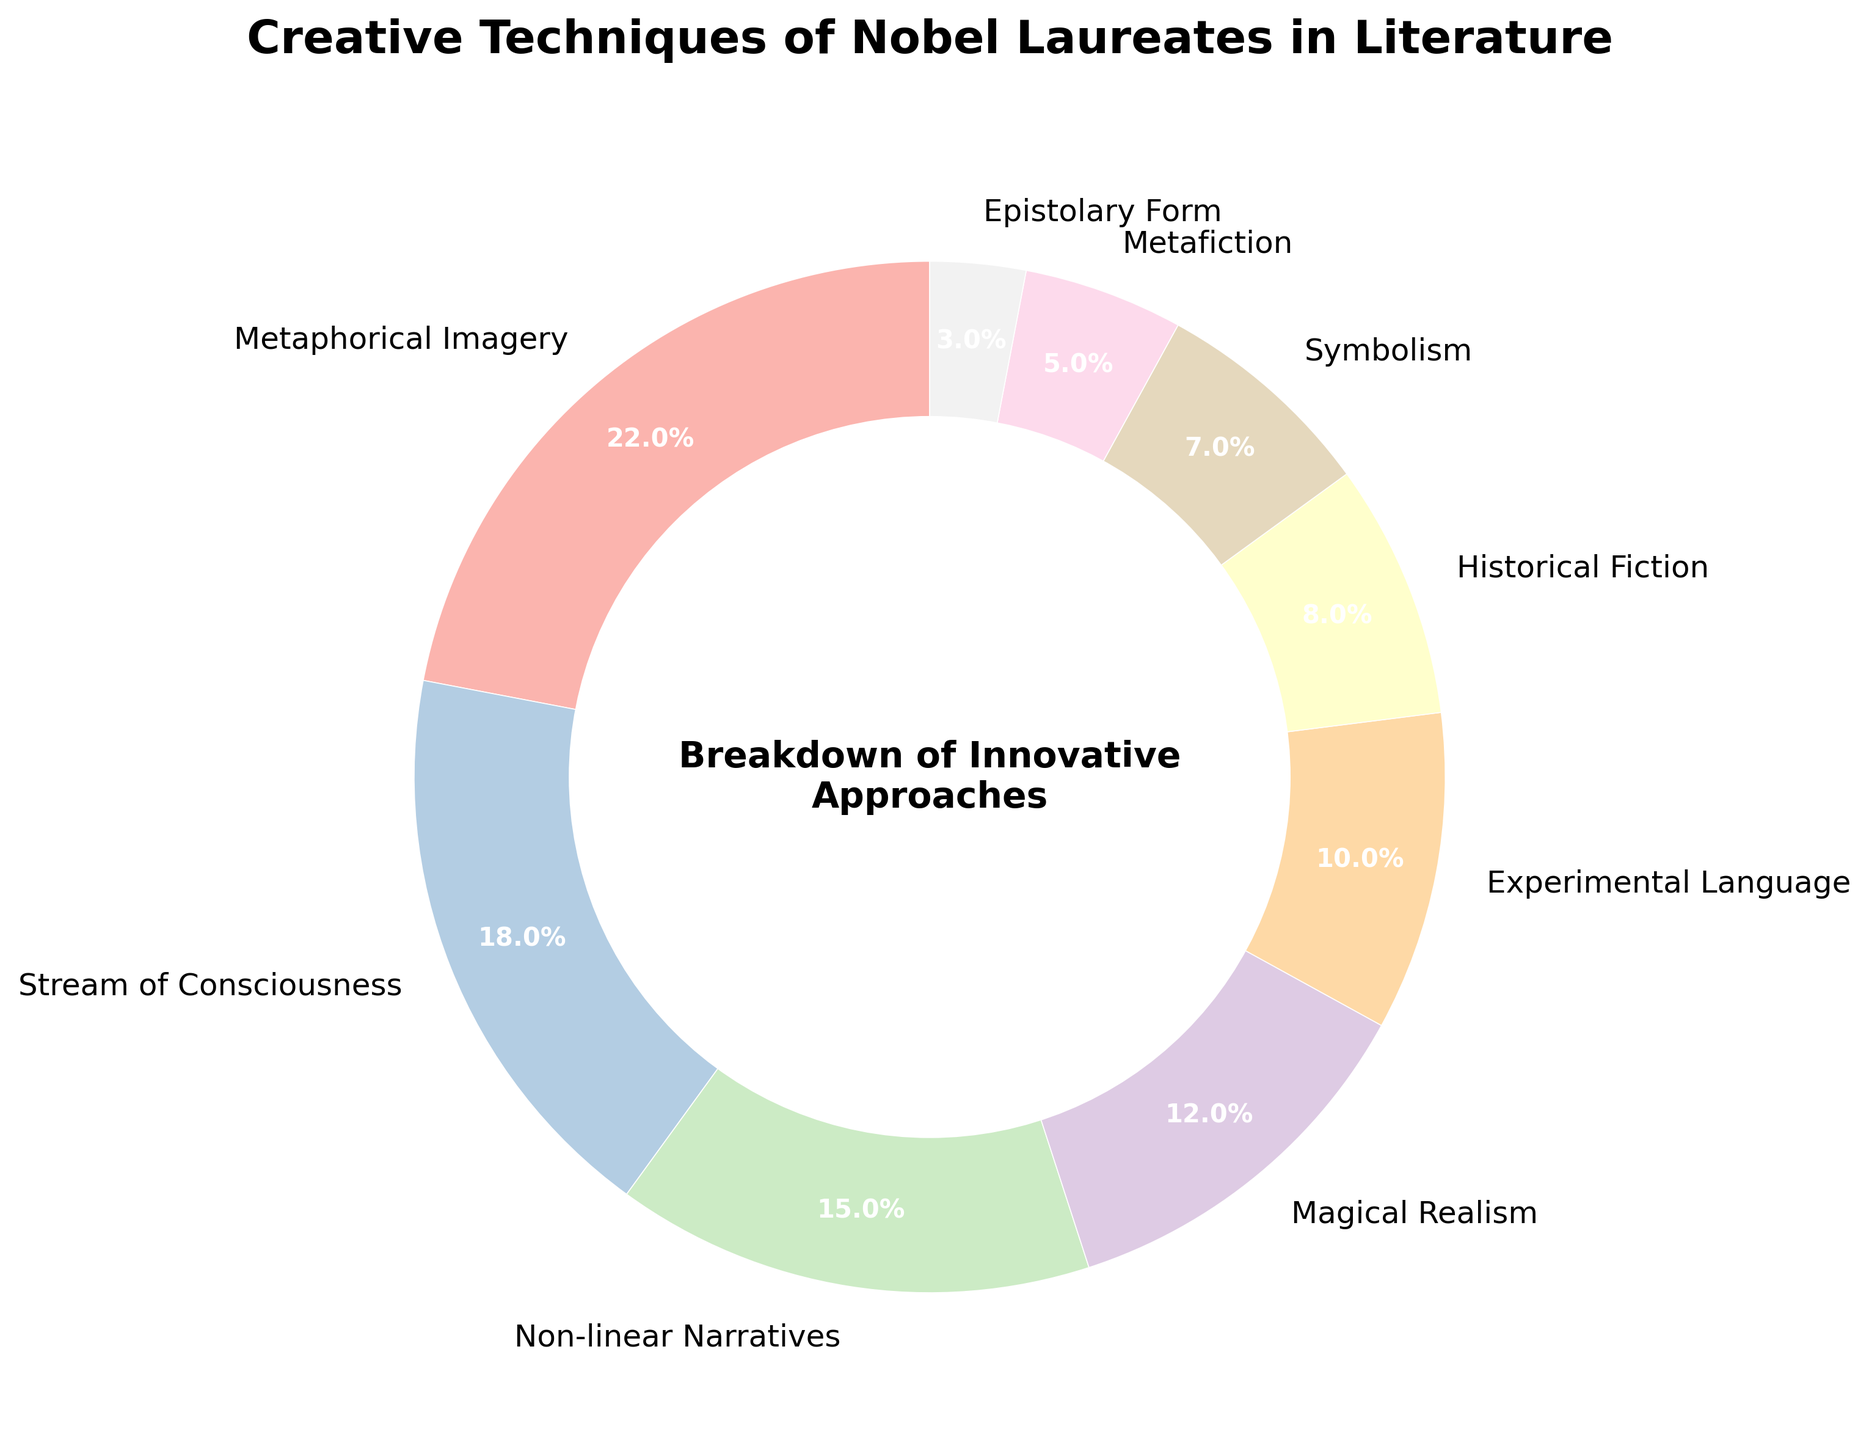Which technique is used the most by Nobel laureates in literature? By referring to the pie chart, the largest segment will indicate the technique with the highest percentage. The largest portion belongs to "Metaphorical Imagery" at 22%.
Answer: Metaphorical Imagery What is the combined percentage of "Stream of Consciousness" and "Non-linear Narratives"? From the pie chart, "Stream of Consciousness" is 18% and "Non-linear Narratives" is 15%. Summing them gives 18% + 15% = 33%.
Answer: 33% Is "Magical Realism" used more frequently than "Historical Fiction"? Comparing the respective segments on the pie chart, "Magical Realism" has 12%, whereas "Historical Fiction" has 8%. Since 12% is greater than 8%, "Magical Realism" is used more frequently.
Answer: Yes What is the difference in percentage between "Symbolism" and "Epistolary Form"? "Symbolism" has a percentage of 7% and "Epistolary Form" has 3%. The difference is calculated as 7% - 3% = 4%.
Answer: 4% Which techniques combined constitute less than 10% individually? From the pie chart, "Metafiction" at 5% and "Epistolary Form" at 3% are both less than 10%.
Answer: Metafiction, Epistolary Form Which technique has more usage, "Experimental Language" or "Historical Fiction"? Observing the pie chart, "Experimental Language" constitutes 10% and "Historical Fiction" constitutes 8%. Hence, "Experimental Language" has more usage.
Answer: Experimental Language How much more frequently is "Metaphorical Imagery" used compared to "Symbolism"? "Metaphorical Imagery" has a 22% usage rate, and "Symbolism" has a 7% rate. The difference is calculated as 22% - 7% = 15%.
Answer: 15% Which technique has the smallest percentage and what is it? The smallest segment on the pie chart represents "Epistolary Form" with 3%.
Answer: Epistolary Form, 3% What is the total percentage for all symbolically rich techniques combined (i.e., Metaphorical Imagery, Symbolism, and Magical Realism)? Adding the percentages from the pie chart: Metaphorical Imagery (22%), Symbolism (7%), and Magical Realism (12%). Therefore, 22% + 7% + 12% = 41%.
Answer: 41% 